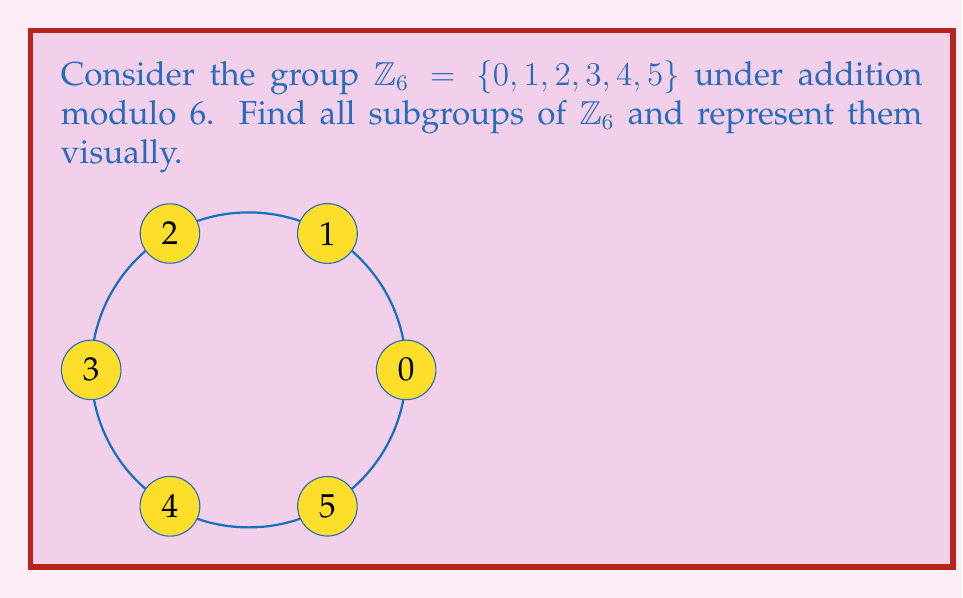Help me with this question. To find all subgroups of $\mathbb{Z}_6$, we'll follow these steps:

1) First, recall that the order of a subgroup must divide the order of the group. The order of $\mathbb{Z}_6$ is 6, so possible orders of subgroups are 1, 2, 3, and 6.

2) The trivial subgroup $\{0\}$ is always a subgroup of order 1.

3) To find subgroups of order 2, we need to find elements of order 2. In $\mathbb{Z}_6$, only 3 has order 2 because $3 + 3 \equiv 0 \pmod{6}$. So $\{0, 3\}$ is a subgroup of order 2.

4) For subgroups of order 3, we need to find elements of order 3. In $\mathbb{Z}_6$, 2 and 4 have order 3 because:
   $2 + 2 + 2 \equiv 0 \pmod{6}$ and $4 + 4 + 4 \equiv 0 \pmod{6}$
   The subgroup generated by 2 (or 4) is $\{0, 2, 4\}$.

5) The entire group $\mathbb{Z}_6$ is trivially a subgroup of itself, of order 6.

6) We can verify that there are no other subgroups by checking that 1 and 5 generate the entire group $\mathbb{Z}_6$.

Therefore, the subgroups of $\mathbb{Z}_6$ are:
- $\{0\}$ (order 1)
- $\{0, 3\}$ (order 2)
- $\{0, 2, 4\}$ (order 3)
- $\{0, 1, 2, 3, 4, 5\}$ (order 6)

Visually, we can represent these subgroups on the circle diagram:
- $\{0\}$ is just the point at 0.
- $\{0, 3\}$ forms a diameter of the circle.
- $\{0, 2, 4\}$ forms an equilateral triangle.
- The whole circle represents $\mathbb{Z}_6$ itself.
Answer: $\{0\}$, $\{0, 3\}$, $\{0, 2, 4\}$, $\{0, 1, 2, 3, 4, 5\}$ 